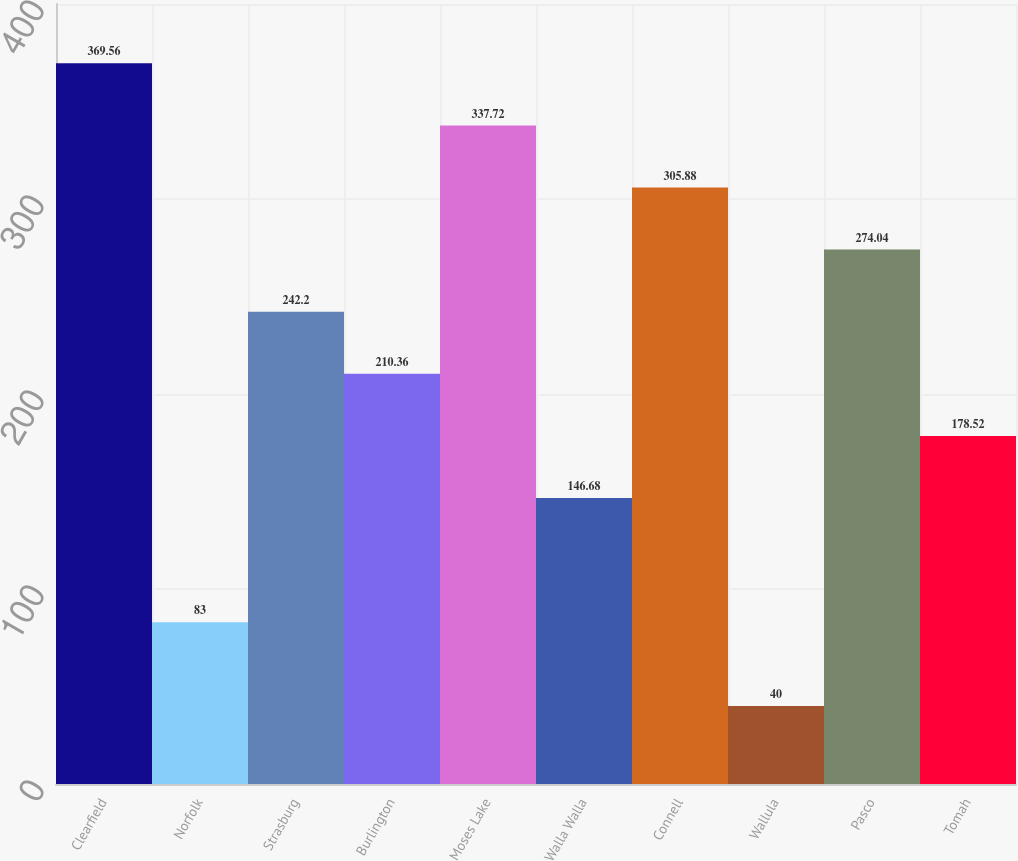<chart> <loc_0><loc_0><loc_500><loc_500><bar_chart><fcel>Clearfield<fcel>Norfolk<fcel>Strasburg<fcel>Burlington<fcel>Moses Lake<fcel>Walla Walla<fcel>Connell<fcel>Wallula<fcel>Pasco<fcel>Tomah<nl><fcel>369.56<fcel>83<fcel>242.2<fcel>210.36<fcel>337.72<fcel>146.68<fcel>305.88<fcel>40<fcel>274.04<fcel>178.52<nl></chart> 